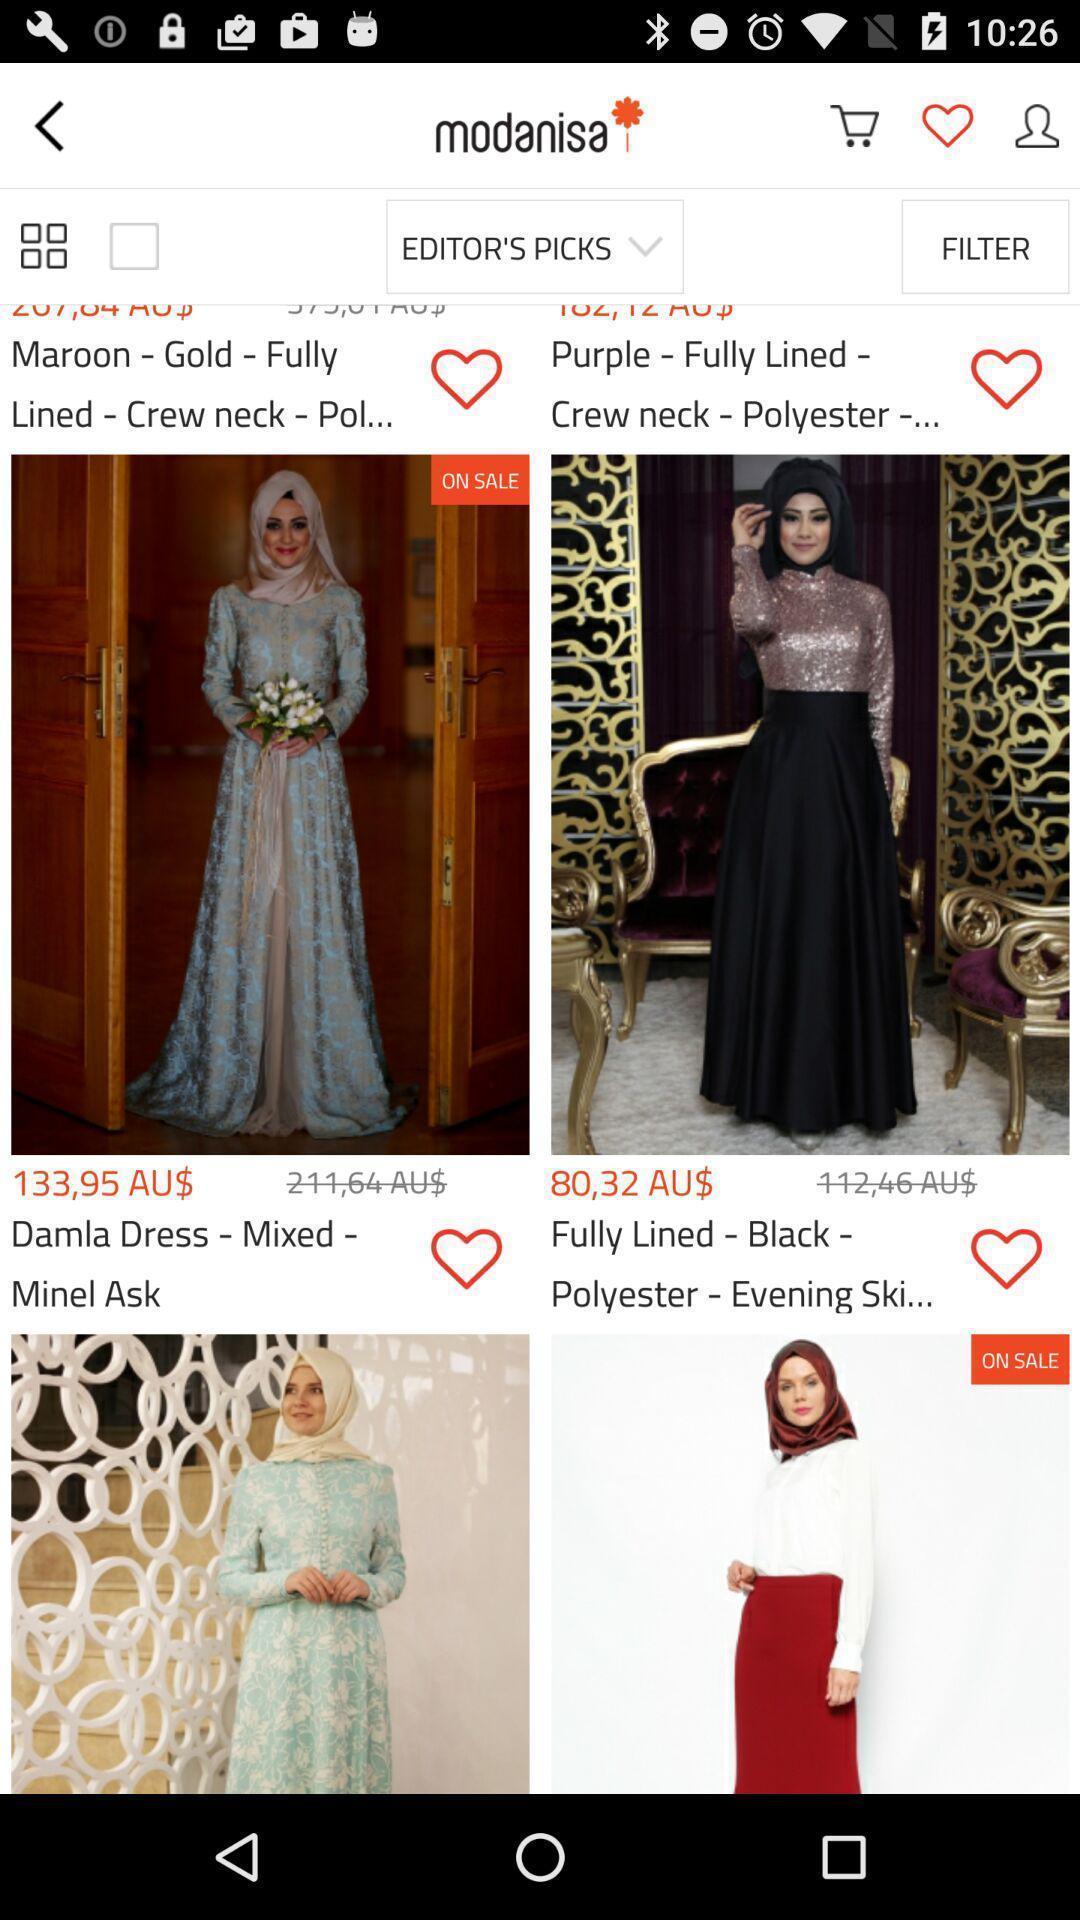Tell me about the visual elements in this screen capture. Screen display various dress designs in a shopping app. 